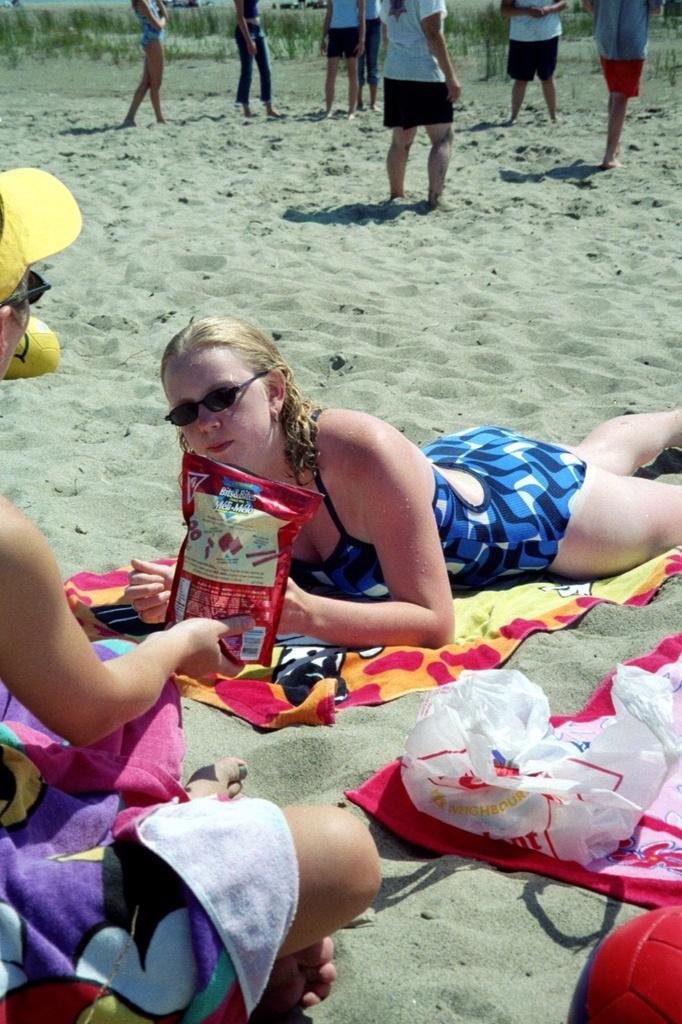How would you summarize this image in a sentence or two? In this image we can see some group of persons wearing bikini sitting and resting on the ground at the seashore and in the background of the image there are some persons standing and there is some grass. 